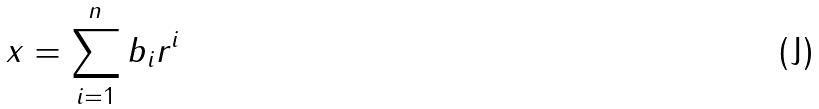Convert formula to latex. <formula><loc_0><loc_0><loc_500><loc_500>x = \sum _ { i = 1 } ^ { n } b _ { i } r ^ { i }</formula> 